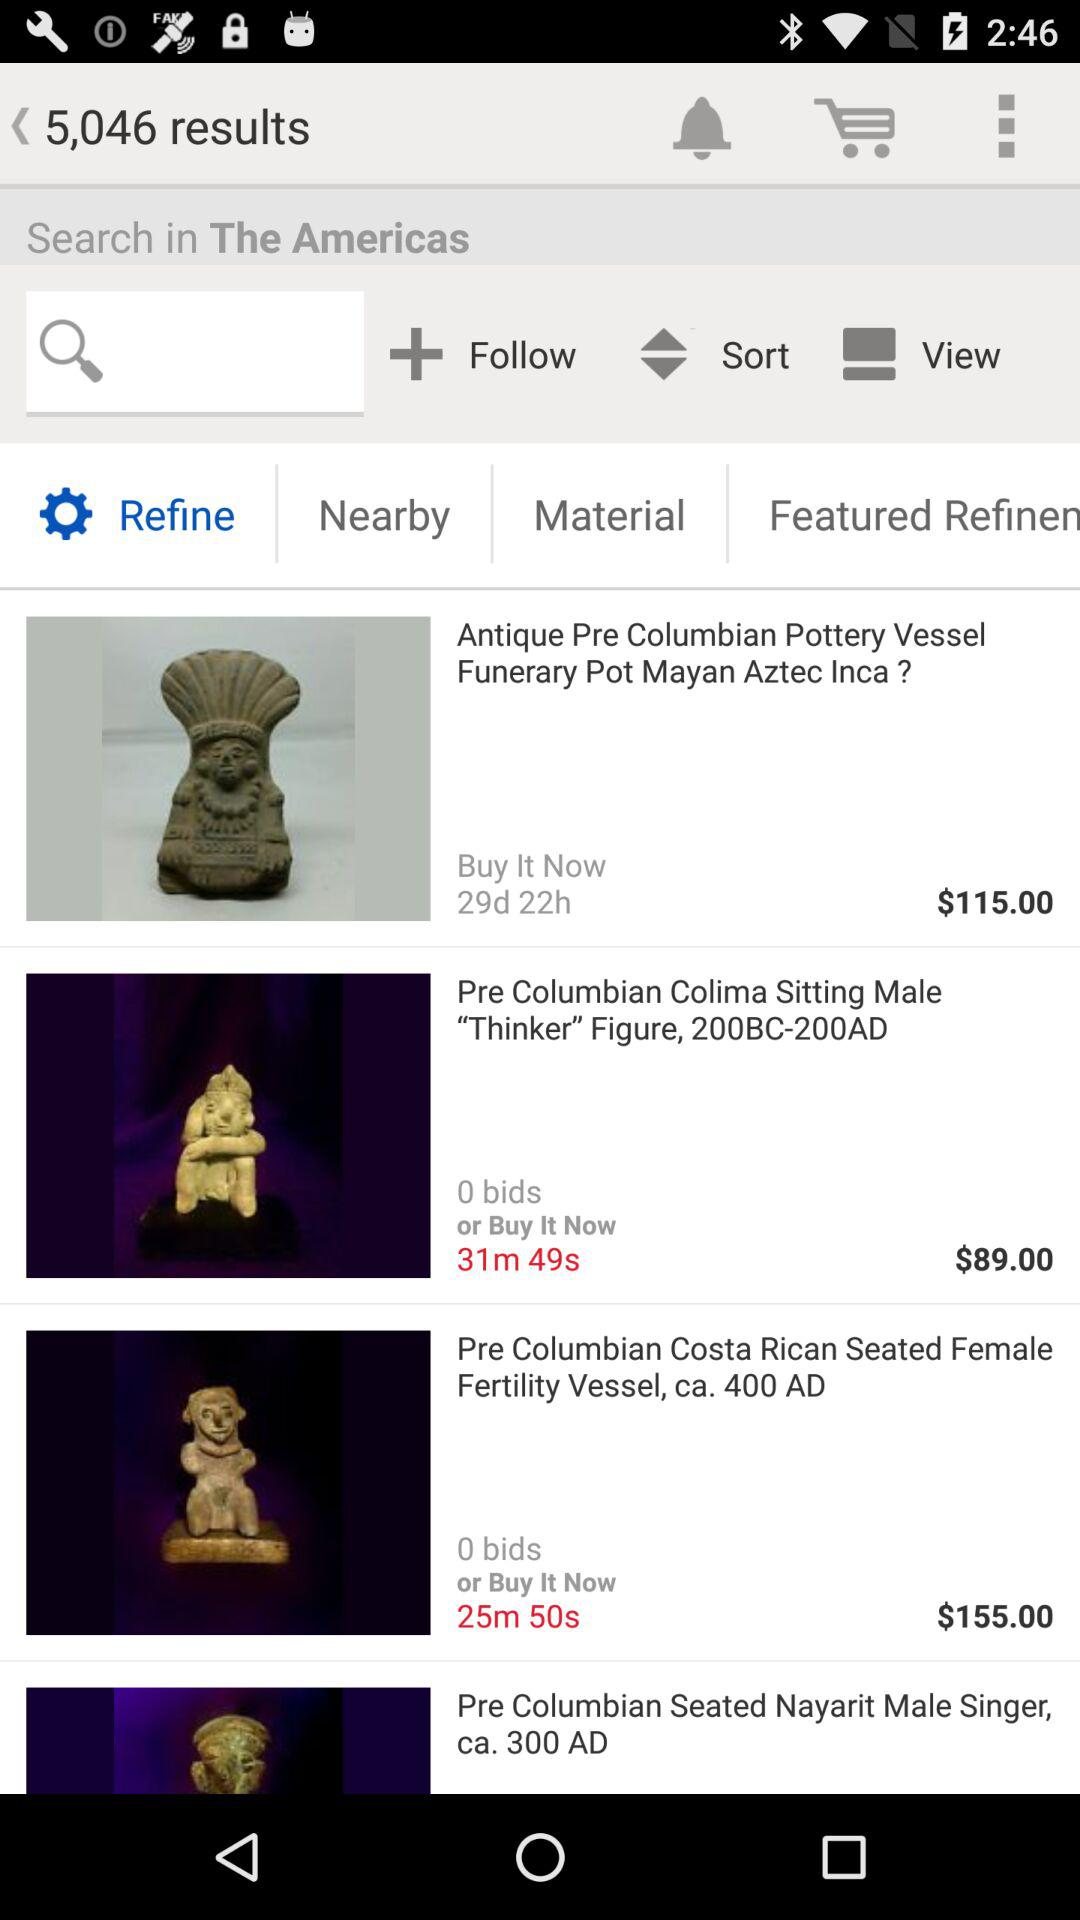How many items have a price of more than $100?
Answer the question using a single word or phrase. 2 